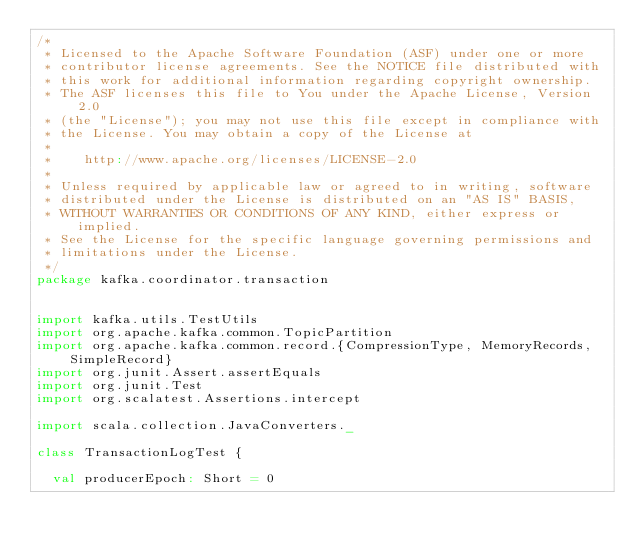Convert code to text. <code><loc_0><loc_0><loc_500><loc_500><_Scala_>/*
 * Licensed to the Apache Software Foundation (ASF) under one or more
 * contributor license agreements. See the NOTICE file distributed with
 * this work for additional information regarding copyright ownership.
 * The ASF licenses this file to You under the Apache License, Version 2.0
 * (the "License"); you may not use this file except in compliance with
 * the License. You may obtain a copy of the License at
 *
 *    http://www.apache.org/licenses/LICENSE-2.0
 *
 * Unless required by applicable law or agreed to in writing, software
 * distributed under the License is distributed on an "AS IS" BASIS,
 * WITHOUT WARRANTIES OR CONDITIONS OF ANY KIND, either express or implied.
 * See the License for the specific language governing permissions and
 * limitations under the License.
 */
package kafka.coordinator.transaction


import kafka.utils.TestUtils
import org.apache.kafka.common.TopicPartition
import org.apache.kafka.common.record.{CompressionType, MemoryRecords, SimpleRecord}
import org.junit.Assert.assertEquals
import org.junit.Test
import org.scalatest.Assertions.intercept

import scala.collection.JavaConverters._

class TransactionLogTest {

  val producerEpoch: Short = 0</code> 